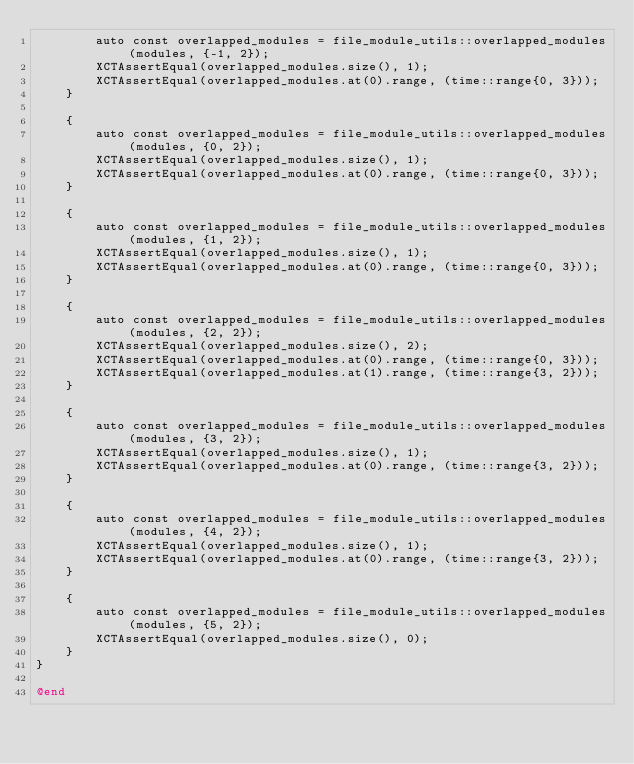<code> <loc_0><loc_0><loc_500><loc_500><_ObjectiveC_>        auto const overlapped_modules = file_module_utils::overlapped_modules(modules, {-1, 2});
        XCTAssertEqual(overlapped_modules.size(), 1);
        XCTAssertEqual(overlapped_modules.at(0).range, (time::range{0, 3}));
    }

    {
        auto const overlapped_modules = file_module_utils::overlapped_modules(modules, {0, 2});
        XCTAssertEqual(overlapped_modules.size(), 1);
        XCTAssertEqual(overlapped_modules.at(0).range, (time::range{0, 3}));
    }

    {
        auto const overlapped_modules = file_module_utils::overlapped_modules(modules, {1, 2});
        XCTAssertEqual(overlapped_modules.size(), 1);
        XCTAssertEqual(overlapped_modules.at(0).range, (time::range{0, 3}));
    }

    {
        auto const overlapped_modules = file_module_utils::overlapped_modules(modules, {2, 2});
        XCTAssertEqual(overlapped_modules.size(), 2);
        XCTAssertEqual(overlapped_modules.at(0).range, (time::range{0, 3}));
        XCTAssertEqual(overlapped_modules.at(1).range, (time::range{3, 2}));
    }

    {
        auto const overlapped_modules = file_module_utils::overlapped_modules(modules, {3, 2});
        XCTAssertEqual(overlapped_modules.size(), 1);
        XCTAssertEqual(overlapped_modules.at(0).range, (time::range{3, 2}));
    }

    {
        auto const overlapped_modules = file_module_utils::overlapped_modules(modules, {4, 2});
        XCTAssertEqual(overlapped_modules.size(), 1);
        XCTAssertEqual(overlapped_modules.at(0).range, (time::range{3, 2}));
    }

    {
        auto const overlapped_modules = file_module_utils::overlapped_modules(modules, {5, 2});
        XCTAssertEqual(overlapped_modules.size(), 0);
    }
}

@end
</code> 